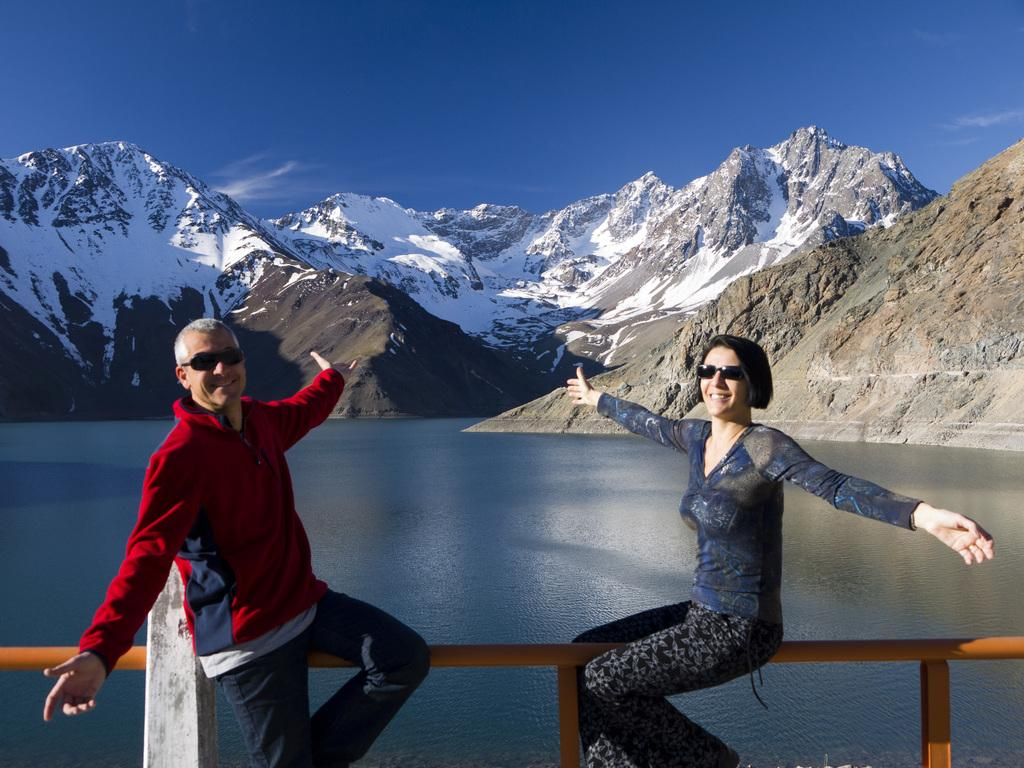Who are the people in the image? There is a man and a woman in the image. What are the man and the woman doing in the image? Both the man and the woman are sitting on a railing. What are the common features of the man and the woman in the image? Both the man and the woman are wearing glasses. What can be seen in the background of the image? There is water, hills, and the sky visible in the background of the image. What is the condition of the hills in the background? There is snow on the hills. What type of box can be seen in the image? There is no box present in the image. Can you describe the yard in the image? There is no yard present in the image; it features a man and a woman sitting on a railing with a snowy hill and water in the background. 